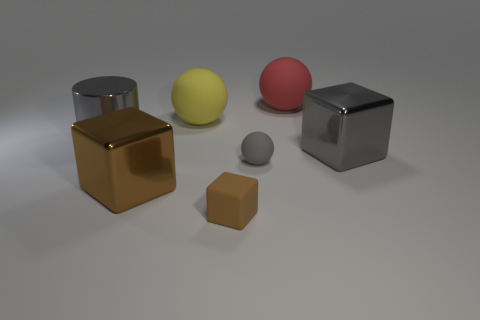Subtract all tiny cubes. How many cubes are left? 2 Subtract all purple spheres. How many brown cubes are left? 2 Add 3 small gray things. How many objects exist? 10 Subtract all yellow balls. How many balls are left? 2 Subtract all cylinders. How many objects are left? 6 Subtract 1 cylinders. How many cylinders are left? 0 Subtract all brown cylinders. Subtract all red spheres. How many cylinders are left? 1 Subtract all red metallic cubes. Subtract all gray metallic cubes. How many objects are left? 6 Add 7 big brown metallic cubes. How many big brown metallic cubes are left? 8 Add 4 small gray things. How many small gray things exist? 5 